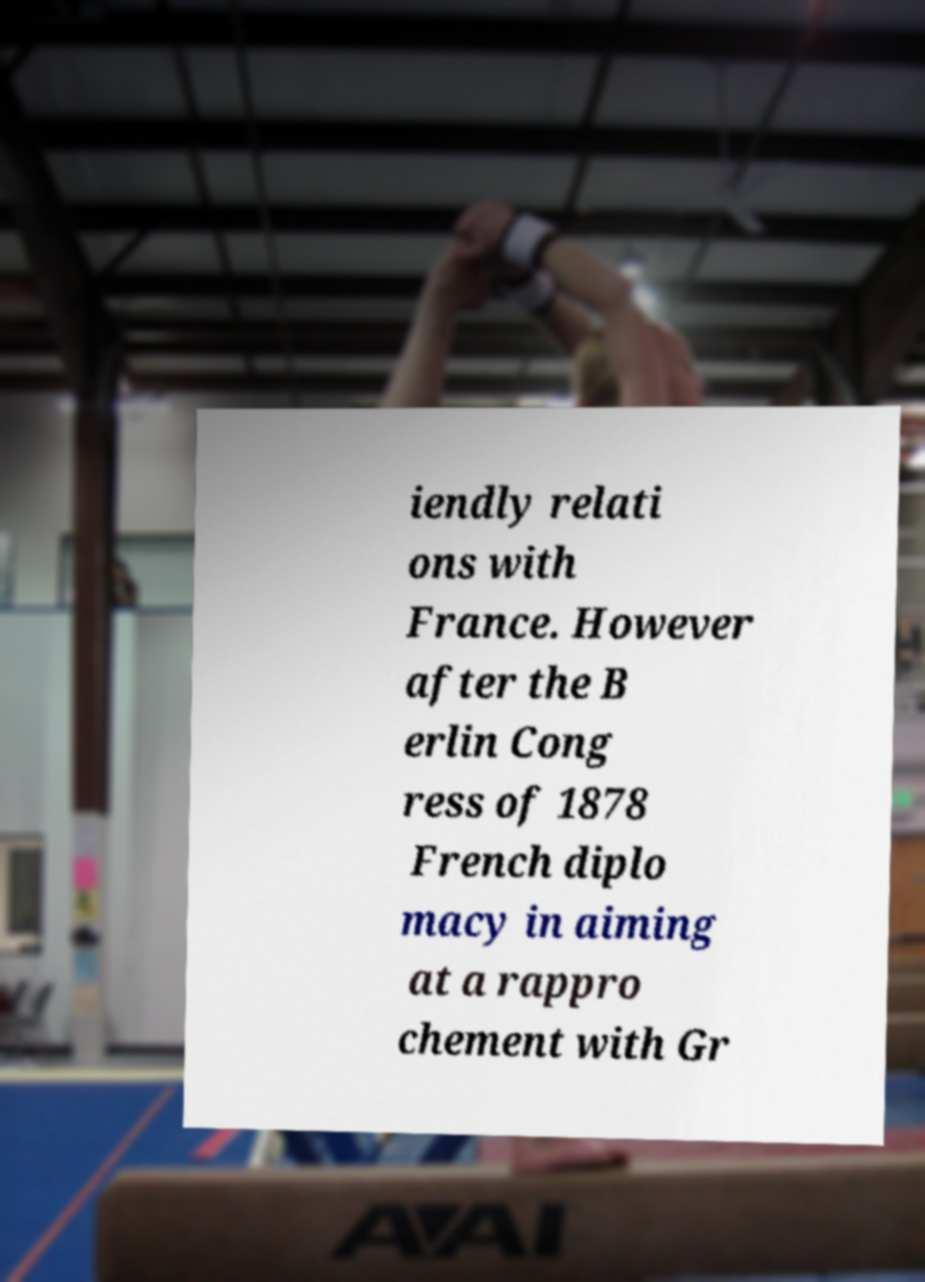Can you read and provide the text displayed in the image?This photo seems to have some interesting text. Can you extract and type it out for me? iendly relati ons with France. However after the B erlin Cong ress of 1878 French diplo macy in aiming at a rappro chement with Gr 